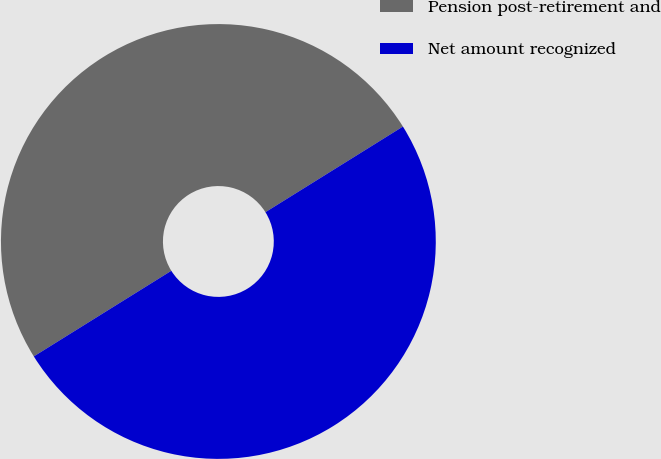Convert chart. <chart><loc_0><loc_0><loc_500><loc_500><pie_chart><fcel>Pension post-retirement and<fcel>Net amount recognized<nl><fcel>50.0%<fcel>50.0%<nl></chart> 